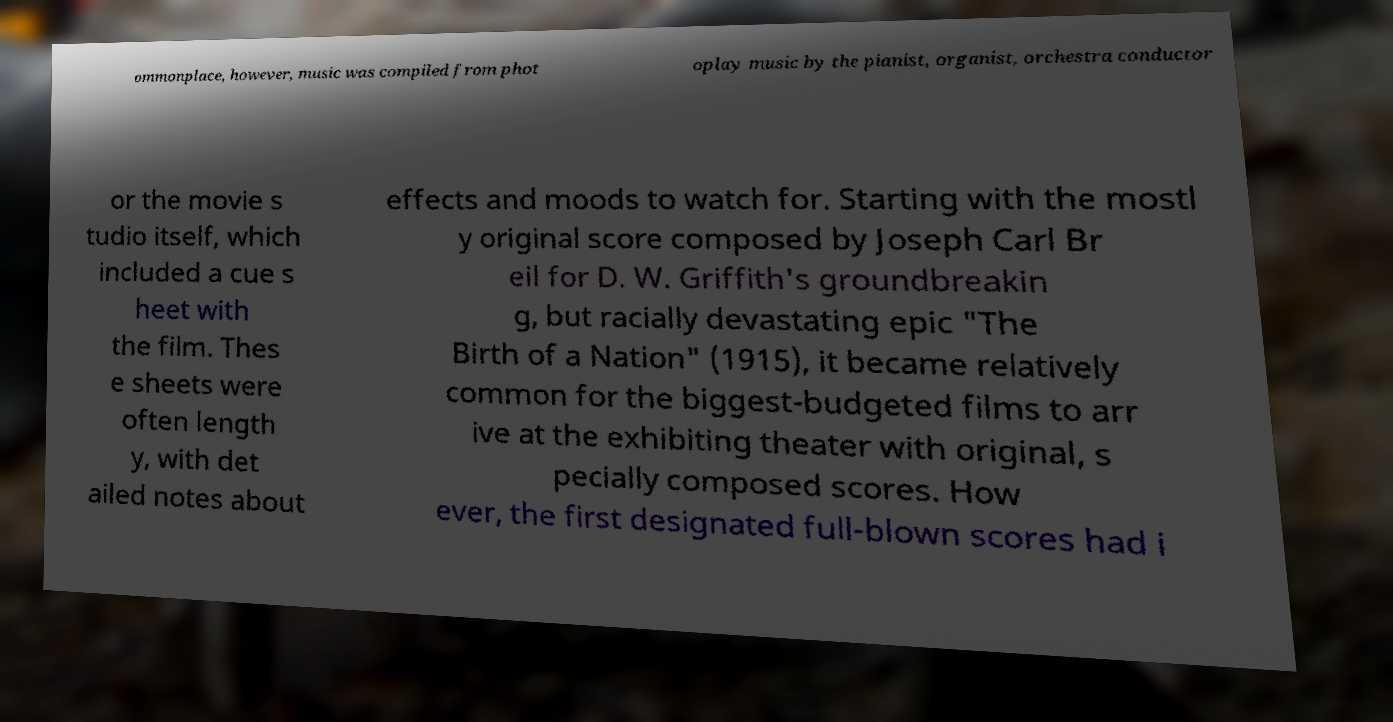There's text embedded in this image that I need extracted. Can you transcribe it verbatim? ommonplace, however, music was compiled from phot oplay music by the pianist, organist, orchestra conductor or the movie s tudio itself, which included a cue s heet with the film. Thes e sheets were often length y, with det ailed notes about effects and moods to watch for. Starting with the mostl y original score composed by Joseph Carl Br eil for D. W. Griffith's groundbreakin g, but racially devastating epic "The Birth of a Nation" (1915), it became relatively common for the biggest-budgeted films to arr ive at the exhibiting theater with original, s pecially composed scores. How ever, the first designated full-blown scores had i 